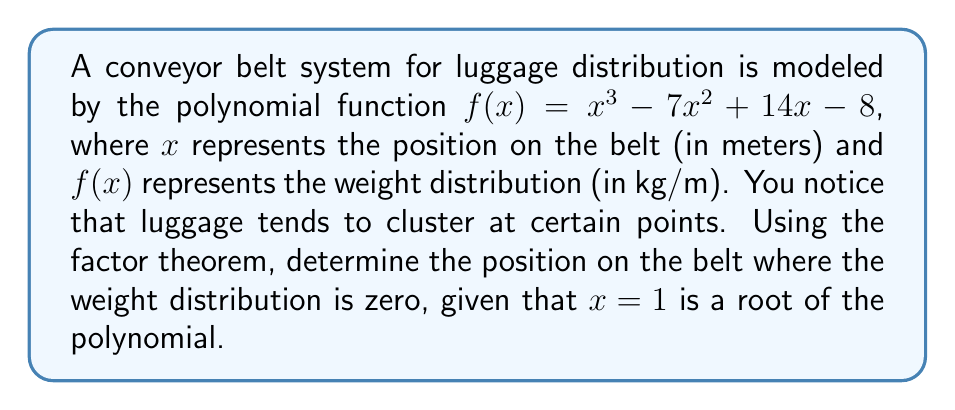Give your solution to this math problem. Let's approach this step-by-step:

1) We're given that $x = 1$ is a root of the polynomial. This means $(x - 1)$ is a factor of $f(x)$.

2) Using polynomial long division or synthetic division, we can divide $f(x)$ by $(x - 1)$:

   $f(x) = (x - 1)(x^2 - 6x + 8)$

3) Now we need to factor the quadratic term $(x^2 - 6x + 8)$:

   $(x^2 - 6x + 8) = (x - 2)(x - 4)$

4) Therefore, the fully factored polynomial is:

   $f(x) = (x - 1)(x - 2)(x - 4)$

5) The roots of this polynomial are the values of $x$ that make $f(x) = 0$. From the factored form, we can see that these roots are $x = 1$, $x = 2$, and $x = 4$.

6) We already knew about $x = 1$. The other positions where the weight distribution is zero are at $x = 2$ and $x = 4$ meters along the conveyor belt.
Answer: 2 meters and 4 meters 